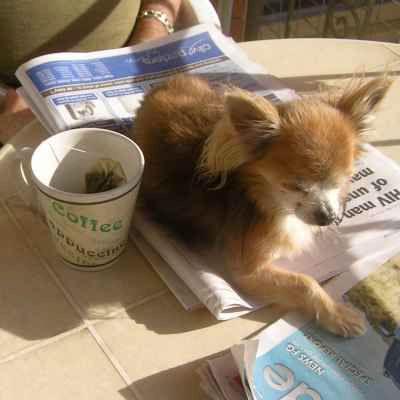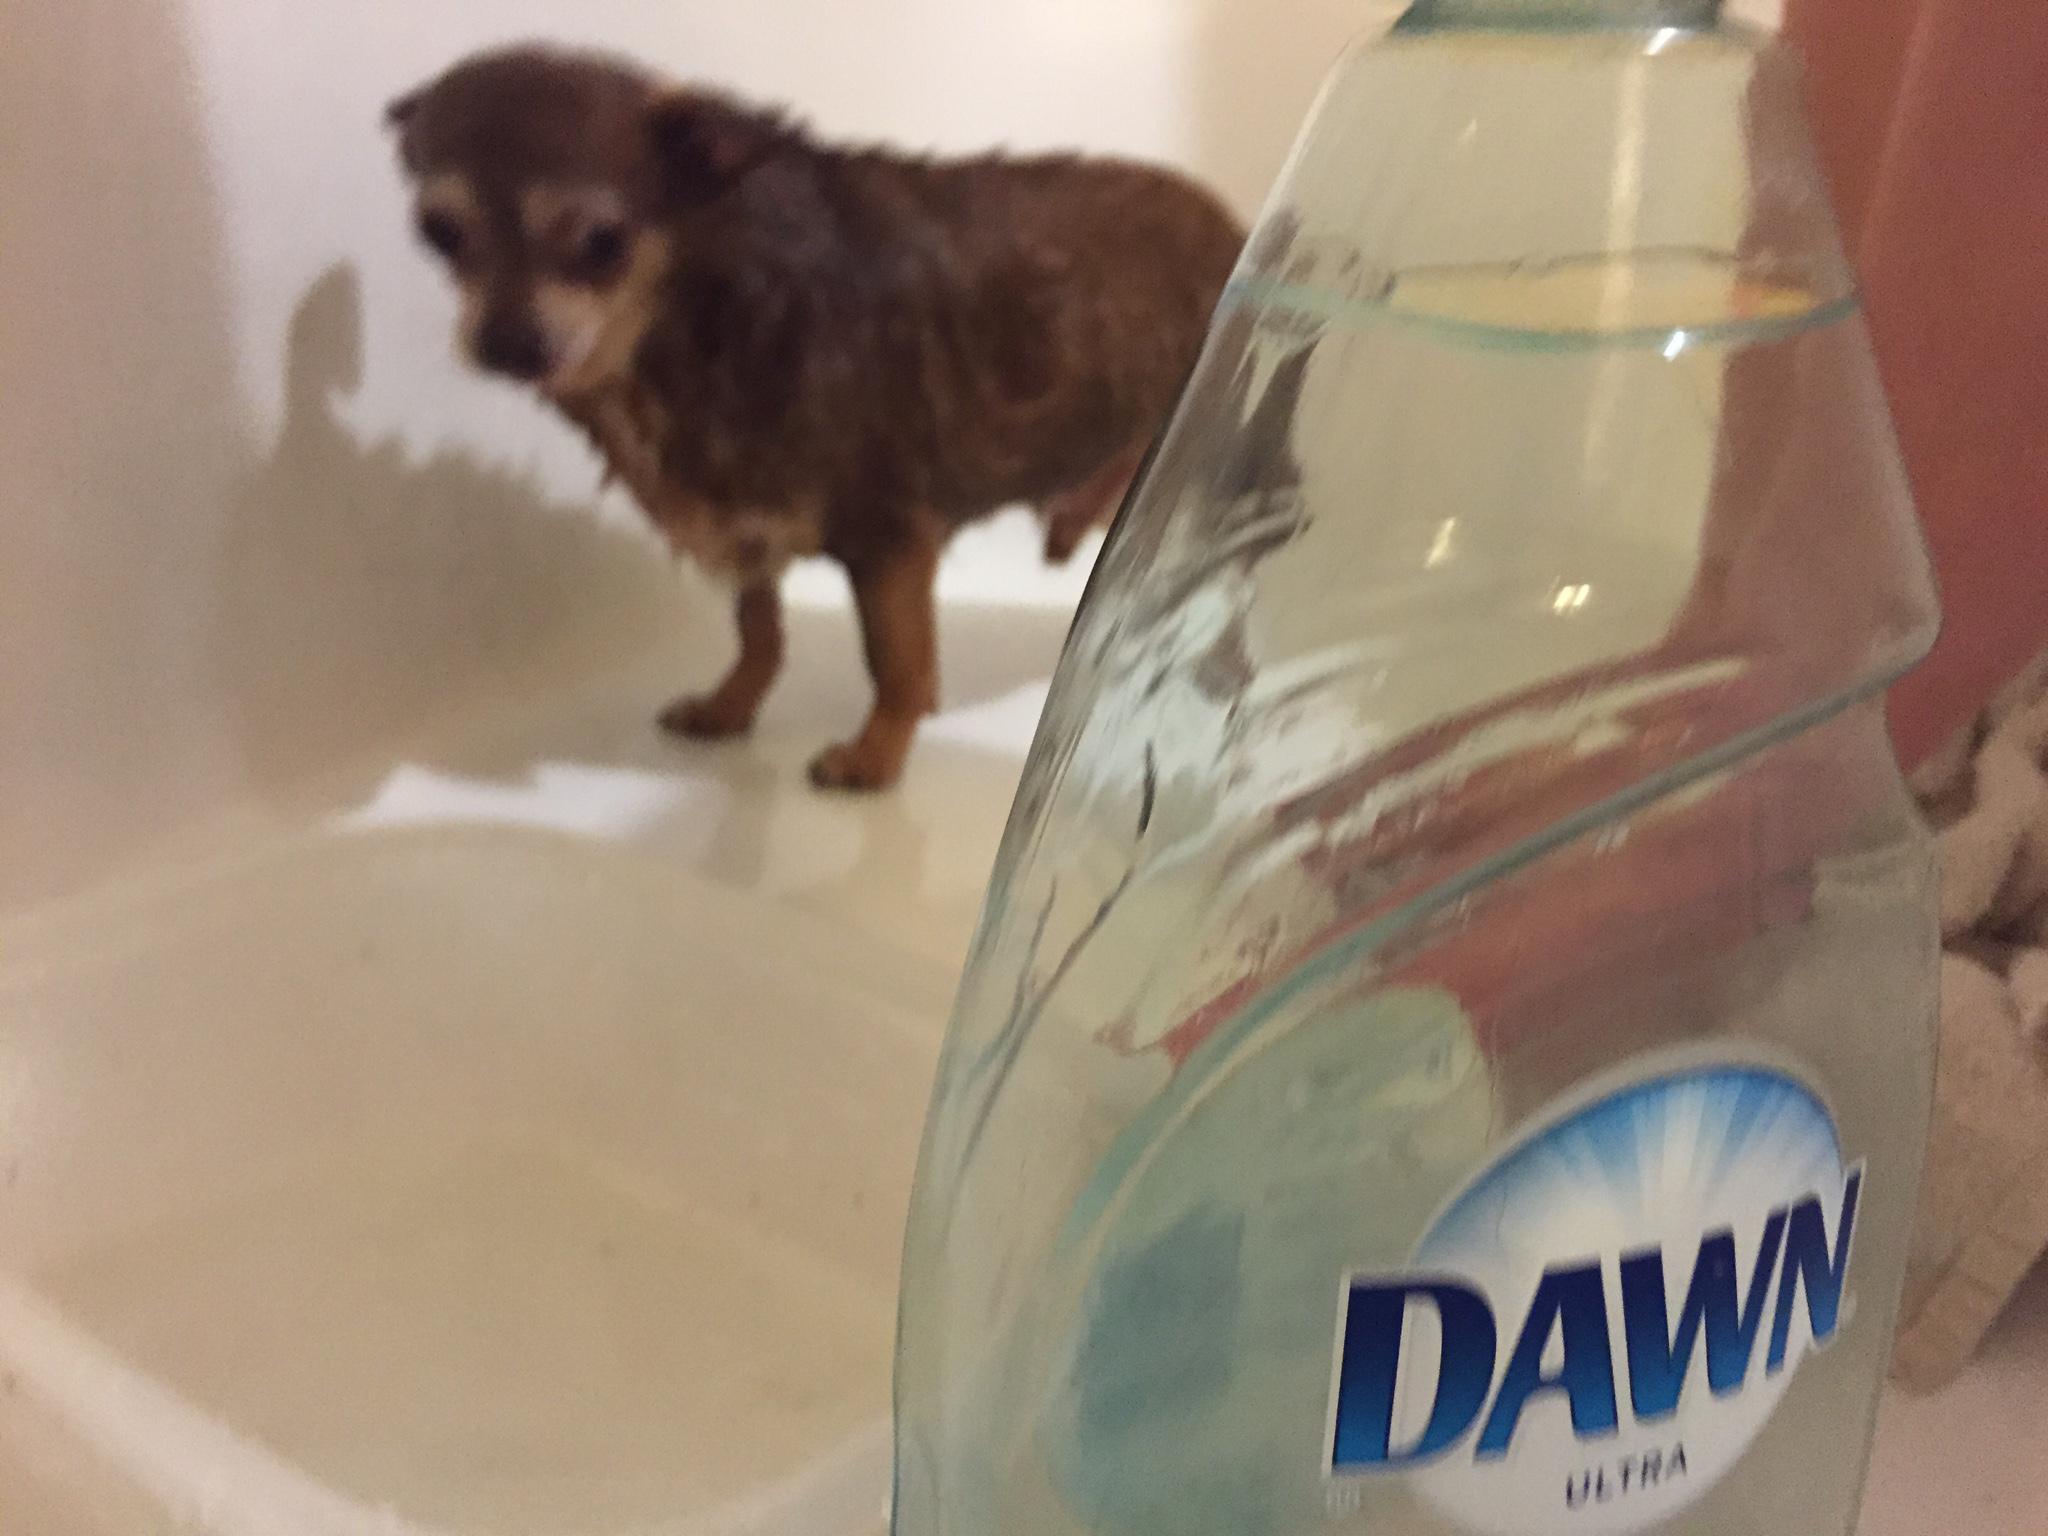The first image is the image on the left, the second image is the image on the right. Considering the images on both sides, is "A cup is pictured with a chihuahua." valid? Answer yes or no. Yes. The first image is the image on the left, the second image is the image on the right. Assess this claim about the two images: "A cup with a handle is pictured with a tiny dog, in one image.". Correct or not? Answer yes or no. Yes. 